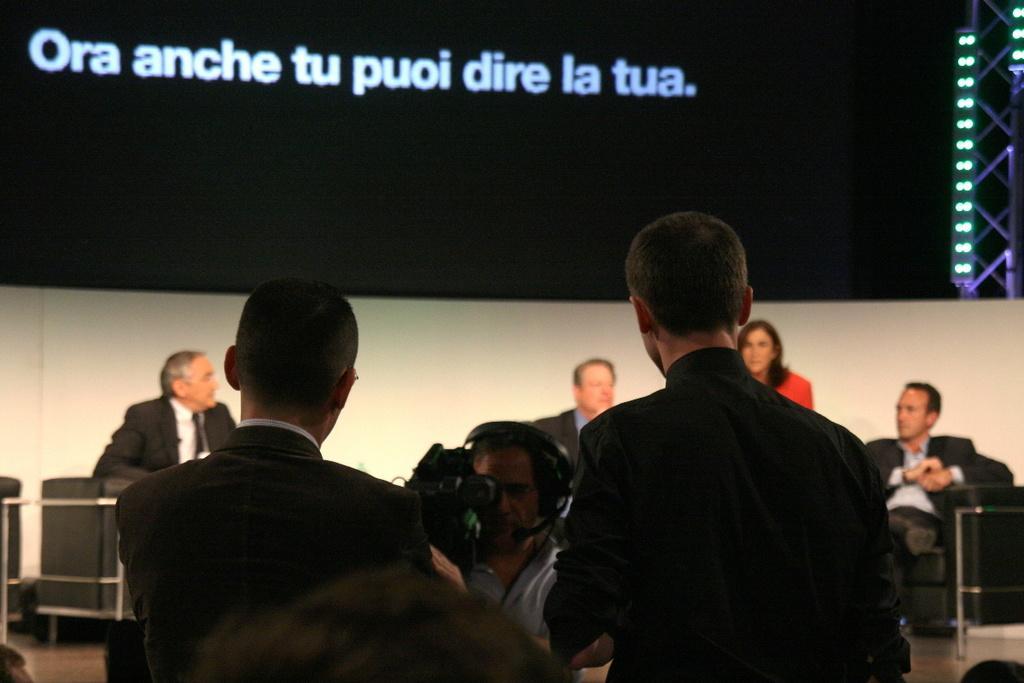Please provide a concise description of this image. In the foreground of the picture there are two men wearing suits. In the center of the picture there is a person holding camera. In the background there are people sitting on the couches. At the top there is led screen. On the right there are lights and an iron frame. 